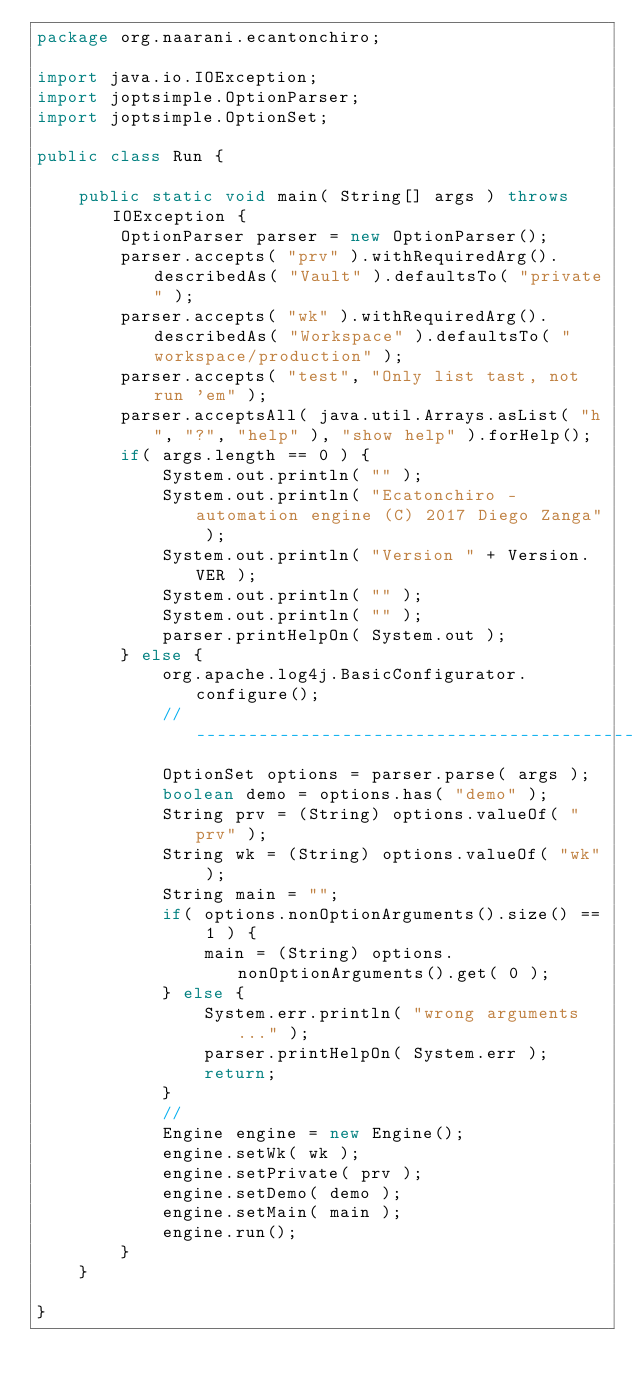<code> <loc_0><loc_0><loc_500><loc_500><_Java_>package org.naarani.ecantonchiro;

import java.io.IOException;
import joptsimple.OptionParser;
import joptsimple.OptionSet;

public class Run {

	public static void main( String[] args ) throws IOException {
		OptionParser parser = new OptionParser();
        parser.accepts( "prv" ).withRequiredArg().describedAs( "Vault" ).defaultsTo( "private" );
        parser.accepts( "wk" ).withRequiredArg().describedAs( "Workspace" ).defaultsTo( "workspace/production" );
        parser.accepts( "test", "Only list tast, not run 'em" );
        parser.acceptsAll( java.util.Arrays.asList( "h", "?", "help" ), "show help" ).forHelp();
		if( args.length == 0 ) {
			System.out.println( "" );
			System.out.println( "Ecatonchiro - automation engine (C) 2017 Diego Zanga" );
			System.out.println( "Version " + Version.VER );
			System.out.println( "" );
			System.out.println( "" );
			parser.printHelpOn( System.out );
		} else {
			org.apache.log4j.BasicConfigurator.configure();
			// --------------------------------------------------------------------
	        OptionSet options = parser.parse( args );
	        boolean demo = options.has( "demo" );
	        String prv = (String) options.valueOf( "prv" );
	        String wk = (String) options.valueOf( "wk" );
	        String main = "";
	        if( options.nonOptionArguments().size() == 1 ) {
		        main = (String) options.nonOptionArguments().get( 0 );
	        } else {
				System.err.println( "wrong arguments..." );
				parser.printHelpOn( System.err );
	        	return;
	        } 
	        //
	        Engine engine = new Engine();
			engine.setWk( wk );
			engine.setPrivate( prv );
			engine.setDemo( demo );
			engine.setMain( main );
			engine.run();
		}
	}

}</code> 